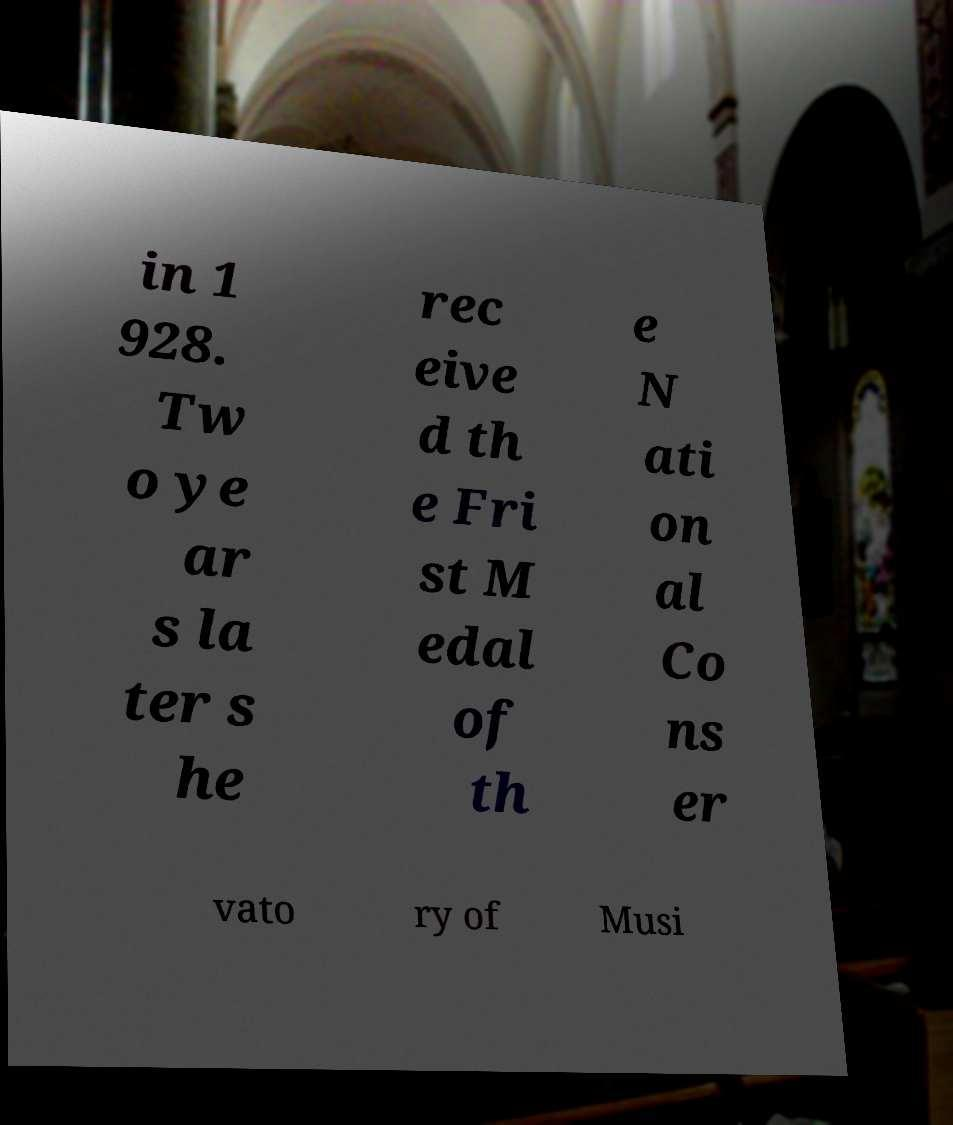I need the written content from this picture converted into text. Can you do that? in 1 928. Tw o ye ar s la ter s he rec eive d th e Fri st M edal of th e N ati on al Co ns er vato ry of Musi 